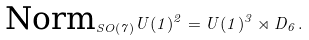<formula> <loc_0><loc_0><loc_500><loc_500>\text {Norm} _ { S O ( 7 ) } U ( 1 ) ^ { 2 } = U ( 1 ) ^ { 3 } \rtimes D _ { 6 } \, .</formula> 